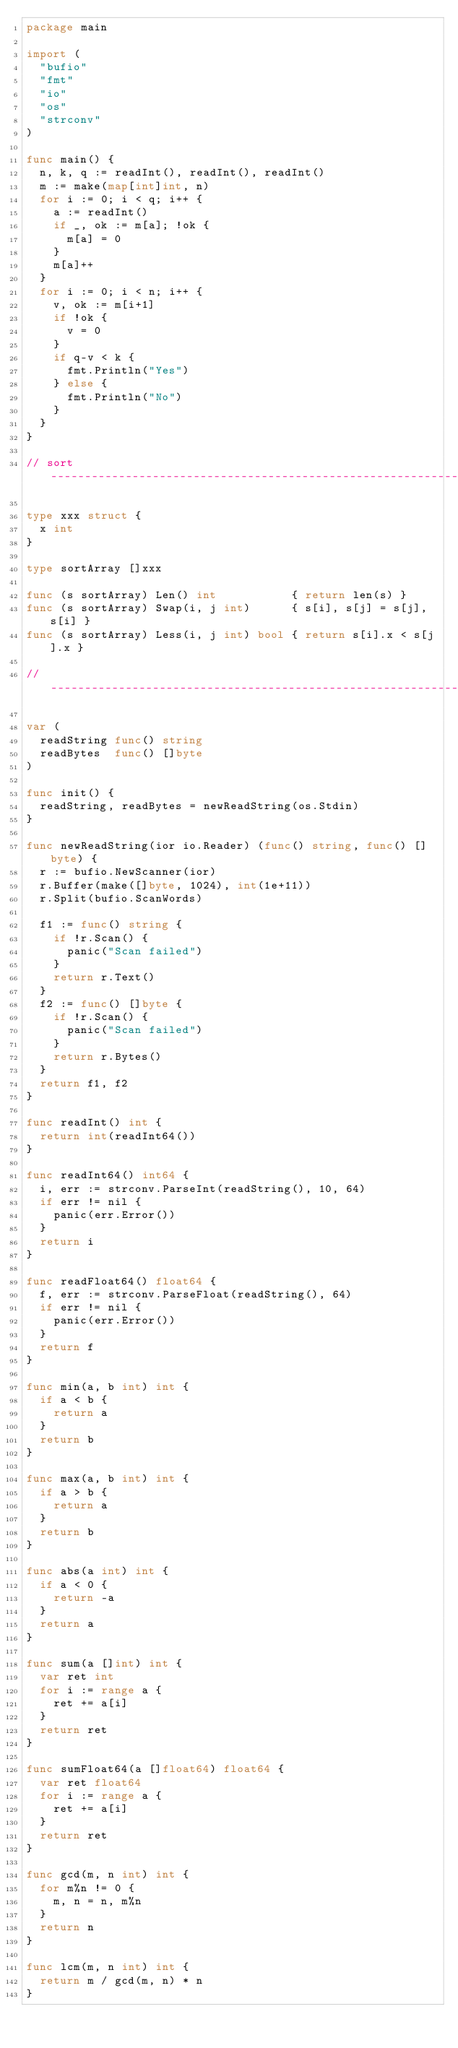<code> <loc_0><loc_0><loc_500><loc_500><_Go_>package main

import (
	"bufio"
	"fmt"
	"io"
	"os"
	"strconv"
)

func main() {
	n, k, q := readInt(), readInt(), readInt()
	m := make(map[int]int, n)
	for i := 0; i < q; i++ {
		a := readInt()
		if _, ok := m[a]; !ok {
			m[a] = 0
		}
		m[a]++
	}
	for i := 0; i < n; i++ {
		v, ok := m[i+1]
		if !ok {
			v = 0
		}
		if q-v < k {
			fmt.Println("Yes")
		} else {
			fmt.Println("No")
		}
	}
}

// sort ------------------------------------------------------------

type xxx struct {
	x int
}

type sortArray []xxx

func (s sortArray) Len() int           { return len(s) }
func (s sortArray) Swap(i, j int)      { s[i], s[j] = s[j], s[i] }
func (s sortArray) Less(i, j int) bool { return s[i].x < s[j].x }

// -----------------------------------------------------------------

var (
	readString func() string
	readBytes  func() []byte
)

func init() {
	readString, readBytes = newReadString(os.Stdin)
}

func newReadString(ior io.Reader) (func() string, func() []byte) {
	r := bufio.NewScanner(ior)
	r.Buffer(make([]byte, 1024), int(1e+11))
	r.Split(bufio.ScanWords)

	f1 := func() string {
		if !r.Scan() {
			panic("Scan failed")
		}
		return r.Text()
	}
	f2 := func() []byte {
		if !r.Scan() {
			panic("Scan failed")
		}
		return r.Bytes()
	}
	return f1, f2
}

func readInt() int {
	return int(readInt64())
}

func readInt64() int64 {
	i, err := strconv.ParseInt(readString(), 10, 64)
	if err != nil {
		panic(err.Error())
	}
	return i
}

func readFloat64() float64 {
	f, err := strconv.ParseFloat(readString(), 64)
	if err != nil {
		panic(err.Error())
	}
	return f
}

func min(a, b int) int {
	if a < b {
		return a
	}
	return b
}

func max(a, b int) int {
	if a > b {
		return a
	}
	return b
}

func abs(a int) int {
	if a < 0 {
		return -a
	}
	return a
}

func sum(a []int) int {
	var ret int
	for i := range a {
		ret += a[i]
	}
	return ret
}

func sumFloat64(a []float64) float64 {
	var ret float64
	for i := range a {
		ret += a[i]
	}
	return ret
}

func gcd(m, n int) int {
	for m%n != 0 {
		m, n = n, m%n
	}
	return n
}

func lcm(m, n int) int {
	return m / gcd(m, n) * n
}
</code> 